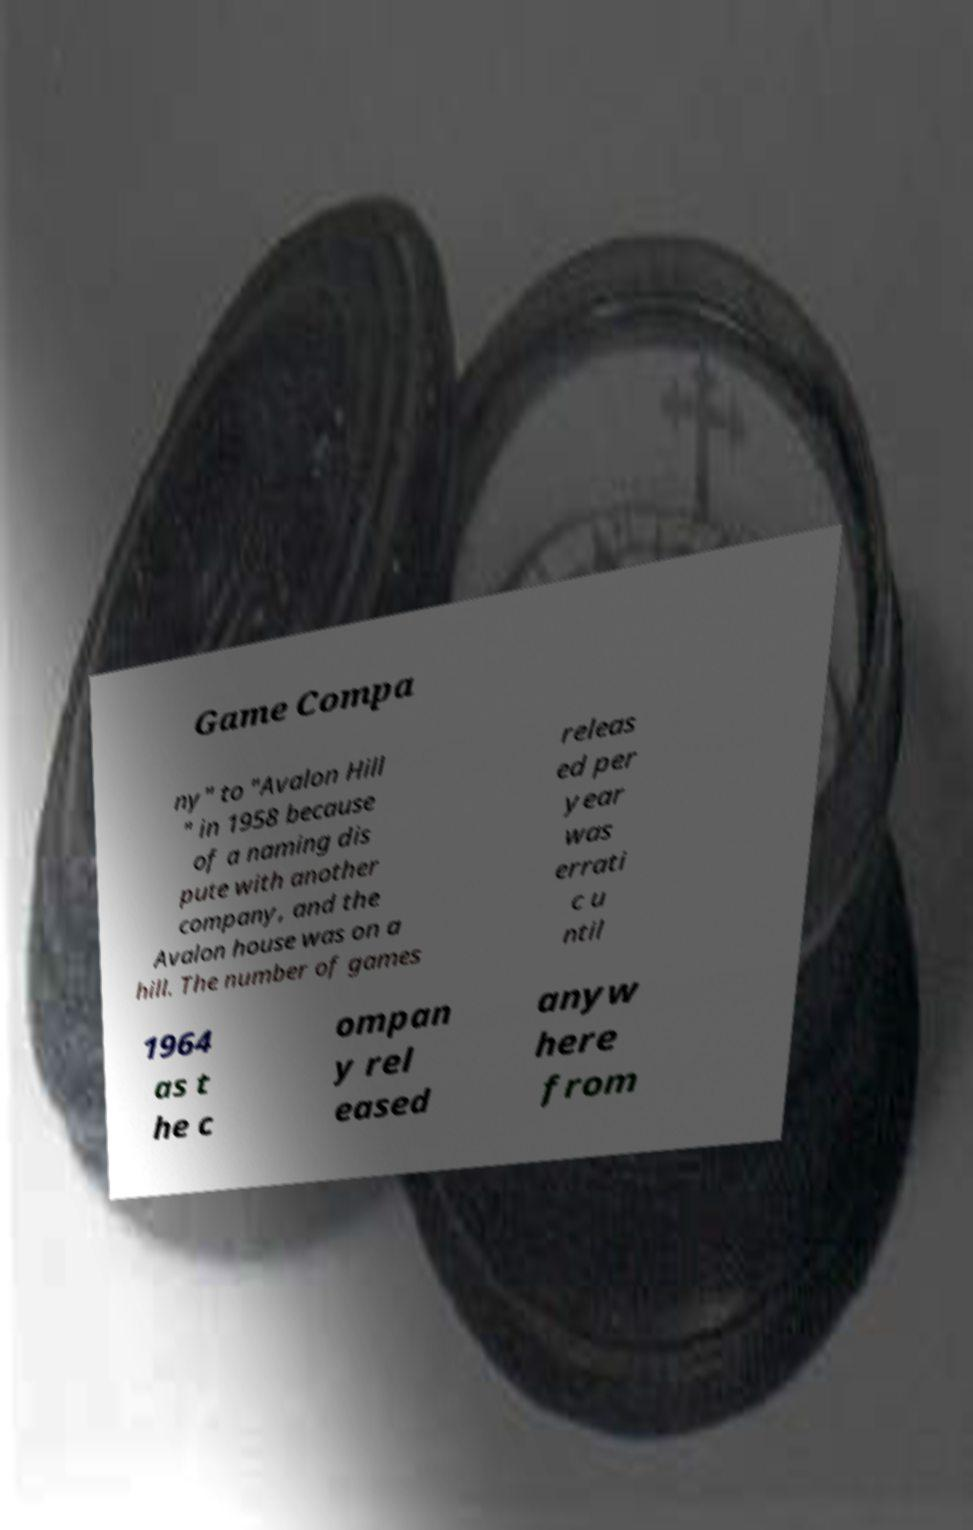Could you assist in decoding the text presented in this image and type it out clearly? Game Compa ny" to "Avalon Hill " in 1958 because of a naming dis pute with another company, and the Avalon house was on a hill. The number of games releas ed per year was errati c u ntil 1964 as t he c ompan y rel eased anyw here from 